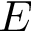Convert formula to latex. <formula><loc_0><loc_0><loc_500><loc_500>E</formula> 